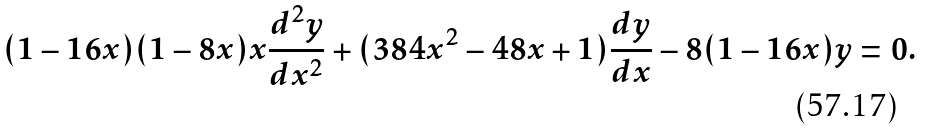<formula> <loc_0><loc_0><loc_500><loc_500>( 1 - 1 6 x ) ( 1 - 8 x ) x \frac { d ^ { 2 } y } { d x ^ { 2 } } + ( 3 8 4 x ^ { 2 } - 4 8 x + 1 ) \frac { d y } { d x } - 8 ( 1 - 1 6 x ) y = 0 .</formula> 